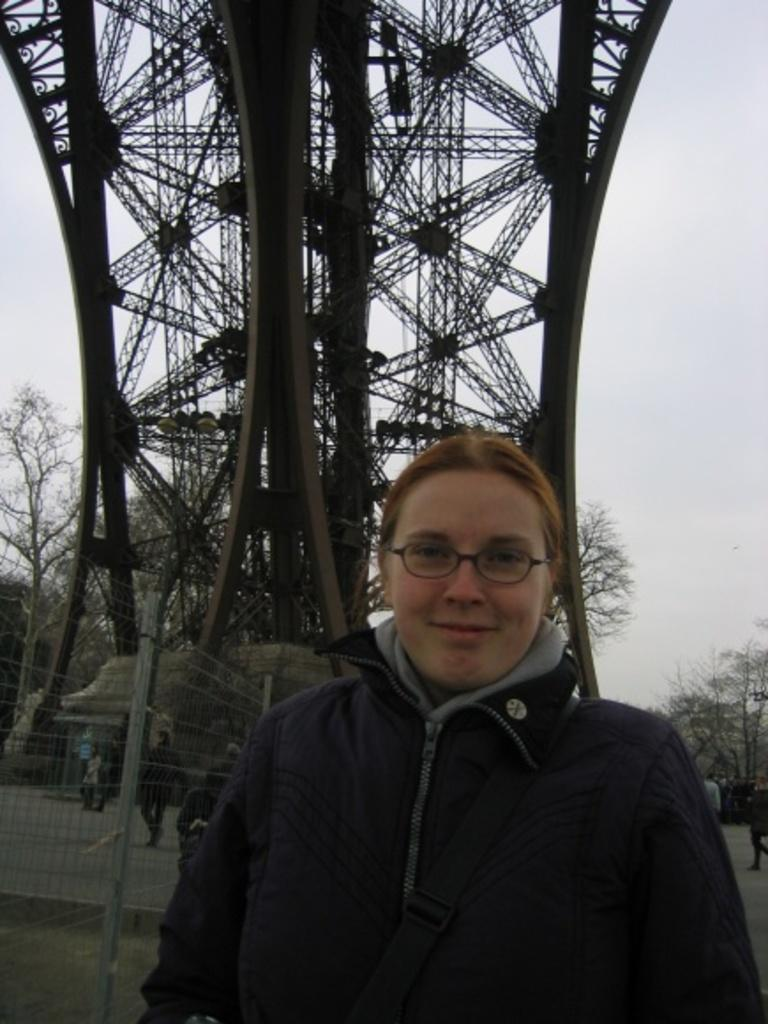Who or what is present in the image? There is a person in the image. What is the person wearing? The person is wearing a black jacket. What type of natural environment is visible in the image? There are trees in the image. What is visible at the top of the image? The sky is visible at the top of the image. What structure can be seen behind the person? There is a tower behind the person. What type of scissors is the person using to cut the tree in the image? There are no scissors or tree-cutting activity present in the image. How does the person show care for the environment in the image? The image does not provide information about the person's actions or intentions regarding the environment. 